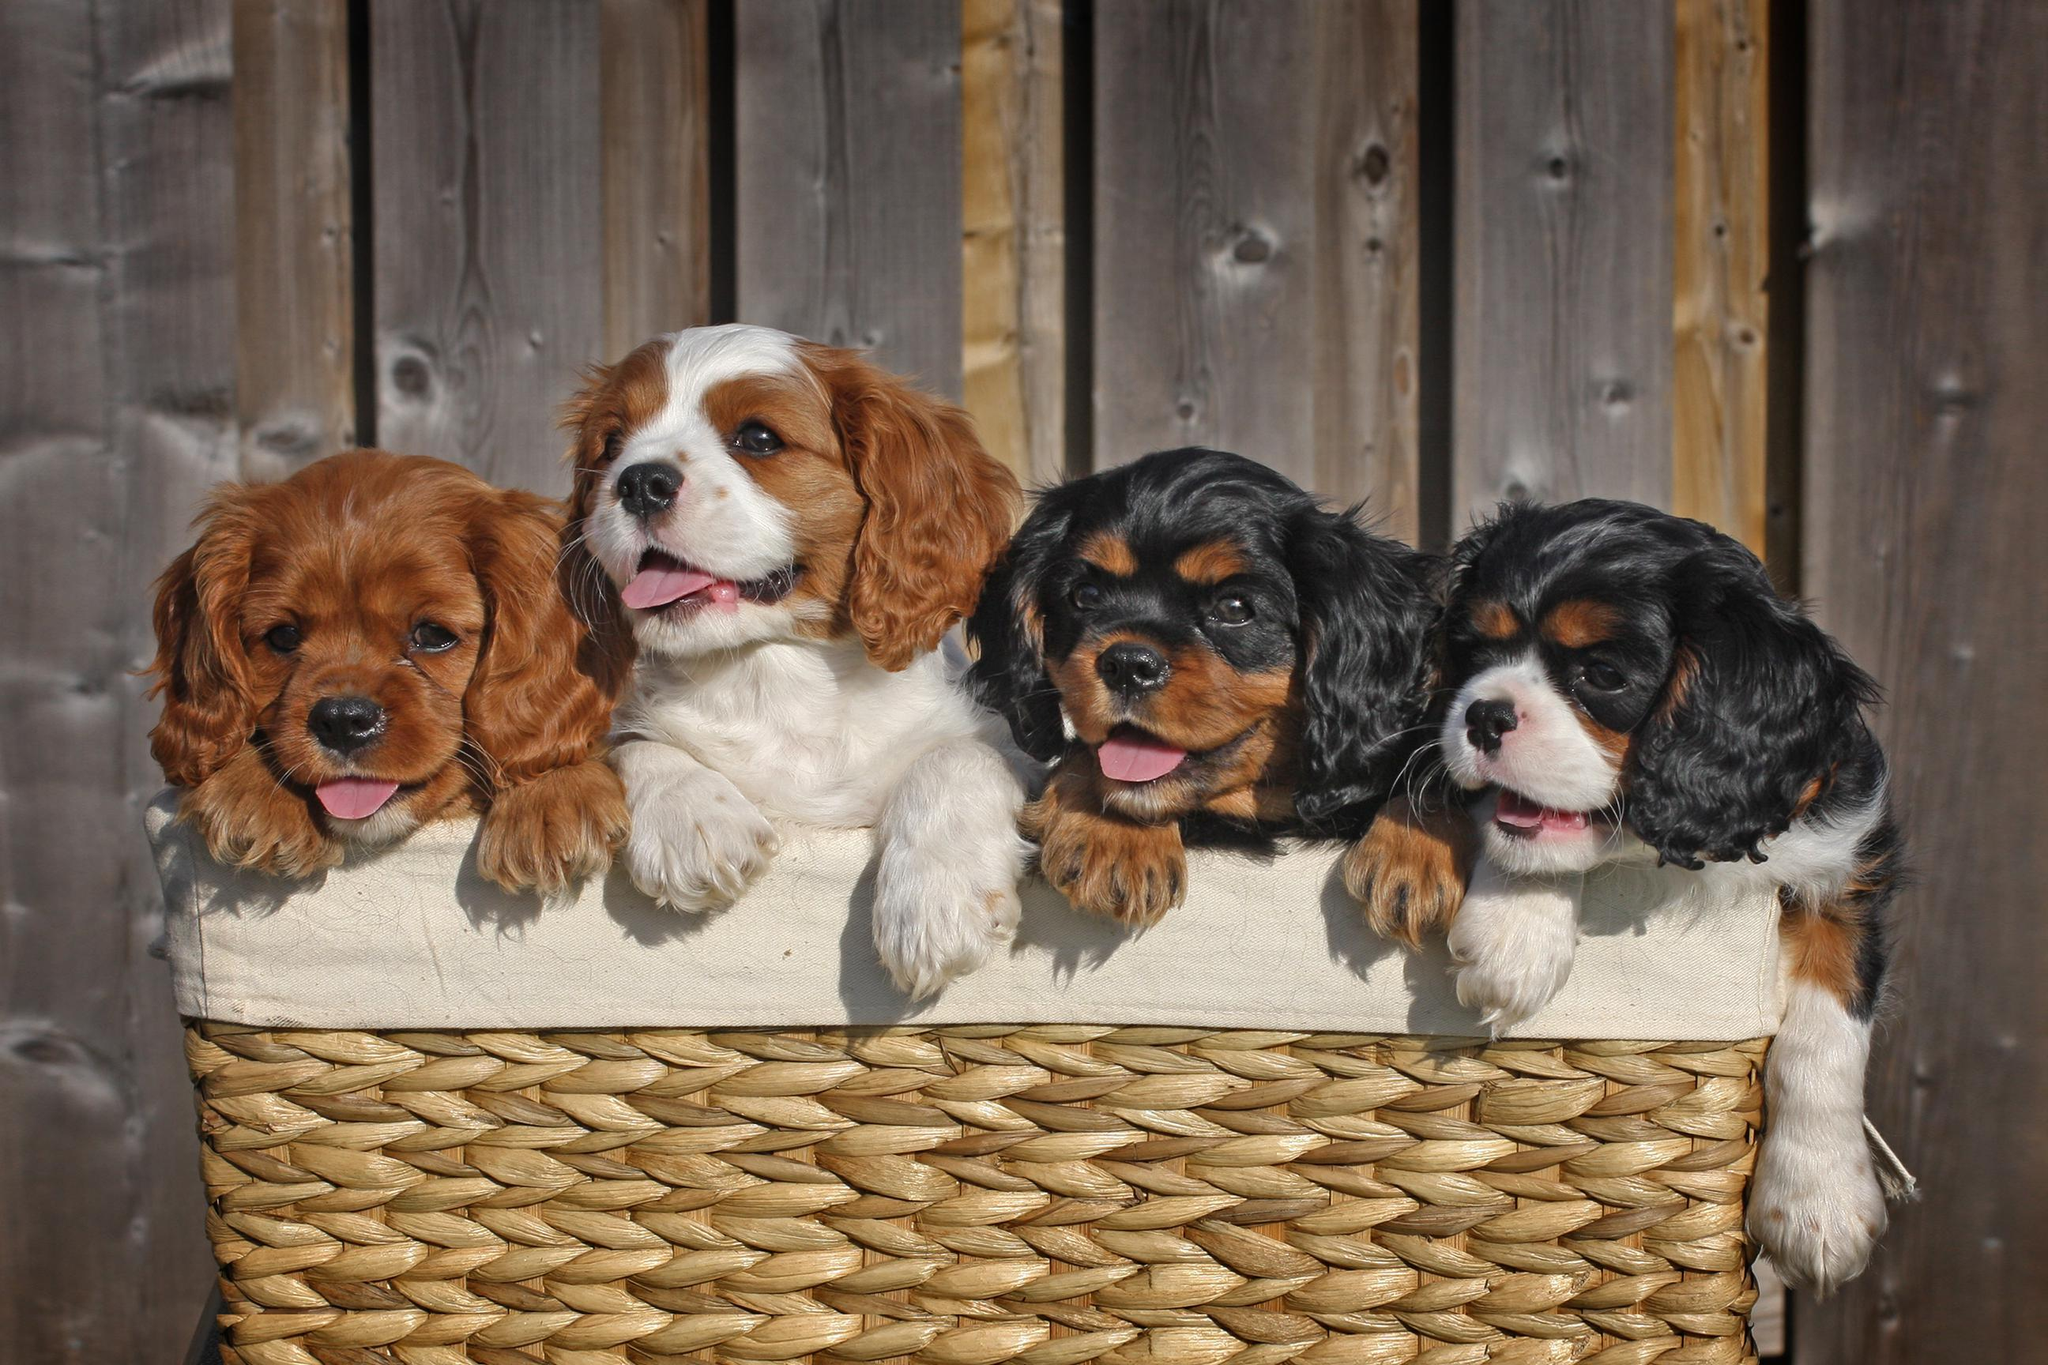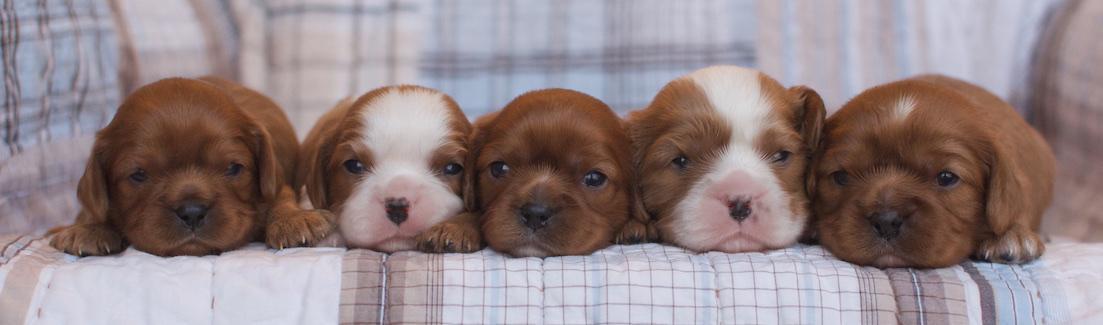The first image is the image on the left, the second image is the image on the right. Evaluate the accuracy of this statement regarding the images: "There are two dogs with black ears and two dogs with brown ears sitting in a row in the image on the left.". Is it true? Answer yes or no. Yes. The first image is the image on the left, the second image is the image on the right. Examine the images to the left and right. Is the description "There are 4 or more puppies being displayed on a cushion." accurate? Answer yes or no. Yes. 